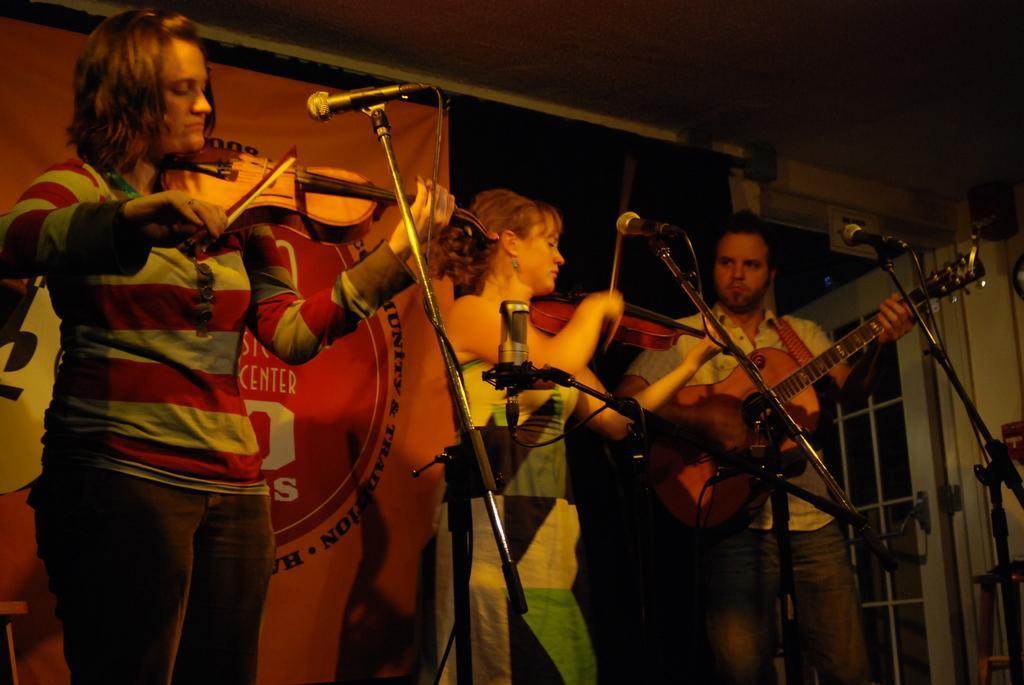Please provide a concise description of this image. In this picture there are two women playing the violin and one man playing the guitar with his right hand and there is a micro phone and microphone stand in front of them. There is a banner behind them. 